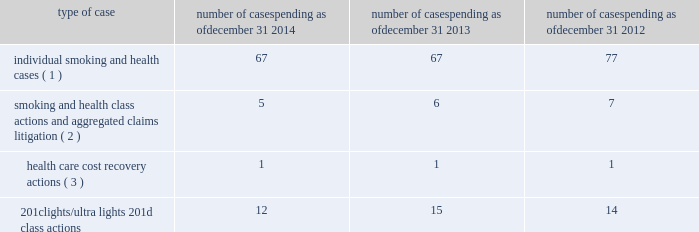Cases ; ( ii ) management is unable to estimate the possible loss or range of loss that could result from an unfavorable outcome in any of the pending tobacco-related cases ; and ( iii ) accordingly , management has not provided any amounts in the consolidated financial statements for unfavorable outcomes , if any .
Legal defense costs are expensed as incurred .
Altria group , inc .
And its subsidiaries have achieved substantial success in managing litigation .
Nevertheless , litigation is subject to uncertainty and significant challenges remain .
It is possible that the consolidated results of operations , cash flows or financial position of altria group , inc. , or one or more of its subsidiaries , could be materially affected in a particular fiscal quarter or fiscal year by an unfavorable outcome or settlement of certain pending litigation .
Altria group , inc .
And each of its subsidiaries named as a defendant believe , and each has been so advised by counsel handling the respective cases , that it has valid defenses to the litigation pending against it , as well as valid bases for appeal of adverse verdicts .
Each of the companies has defended , and will continue to defend , vigorously against litigation challenges .
However , altria group , inc .
And its subsidiaries may enter into settlement discussions in particular cases if they believe it is in the best interests of altria group , inc .
To do so .
Overview of altria group , inc .
And/or pm usa tobacco-related litigation types and number of cases : claims related to tobacco products generally fall within the following categories : ( i ) smoking and health cases alleging personal injury brought on behalf of individual plaintiffs ; ( ii ) smoking and health cases primarily alleging personal injury or seeking court- supervised programs for ongoing medical monitoring and purporting to be brought on behalf of a class of individual plaintiffs , including cases in which the aggregated claims of a number of individual plaintiffs are to be tried in a single proceeding ; ( iii ) health care cost recovery cases brought by governmental ( both domestic and foreign ) plaintiffs seeking reimbursement for health care expenditures allegedly caused by cigarette smoking and/or disgorgement of profits ; ( iv ) class action suits alleging that the uses of the terms 201clights 201d and 201cultra lights 201d constitute deceptive and unfair trade practices , common law or statutory fraud , unjust enrichment , breach of warranty or violations of the racketeer influenced and corrupt organizations act ( 201crico 201d ) ; and ( v ) other tobacco- related litigation described below .
Plaintiffs 2019 theories of recovery and the defenses raised in pending smoking and health , health care cost recovery and 201clights/ultra lights 201d cases are discussed below .
The table below lists the number of certain tobacco-related cases pending in the united states against pm usa and , in some instances , altria group , inc .
As of december 31 , 2014 , december 31 , 2013 and december 31 , 2012 .
Type of case number of cases pending as of december 31 , 2014 number of cases pending as of december 31 , 2013 number of cases pending as of december 31 , 2012 individual smoking and health cases ( 1 ) 67 67 77 smoking and health class actions and aggregated claims litigation ( 2 ) 5 6 7 health care cost recovery actions ( 3 ) 1 1 1 .
( 1 ) does not include 2558 cases brought by flight attendants seeking compensatory damages for personal injuries allegedly caused by exposure to environmental tobacco smoke ( 201cets 201d ) .
The flight attendants allege that they are members of an ets smoking and health class action in florida , which was settled in 1997 ( broin ) .
The terms of the court-approved settlement in that case allow class members to file individual lawsuits seeking compensatory damages , but prohibit them from seeking punitive damages .
Also , does not include individual smoking and health cases brought by or on behalf of plaintiffs in florida state and federal courts following the decertification of the engle case ( discussed below in smoking and health litigation - engle class action ) .
( 2 ) includes as one case the 600 civil actions ( of which 346 were actions against pm usa ) that were to be tried in a single proceeding in west virginia ( in re : tobacco litigation ) .
The west virginia supreme court of appeals has ruled that the united states constitution did not preclude a trial in two phases in this case .
Issues related to defendants 2019 conduct and whether punitive damages are permissible were tried in the first phase .
Trial in the first phase of this case began in april 2013 .
In may 2013 , the jury returned a verdict in favor of defendants on the claims for design defect , negligence , failure to warn , breach of warranty , and concealment and declined to find that the defendants 2019 conduct warranted punitive damages .
Plaintiffs prevailed on their claim that ventilated filter cigarettes should have included use instructions for the period 1964 - 1969 .
The second phase , if any , will consist of individual trials to determine liability and compensatory damages on that claim only .
In august 2013 , the trial court denied all post-trial motions .
The trial court entered final judgment in october 2013 and , in november 2013 , plaintiffs filed their notice of appeal to the west virginia supreme court of appeals .
On november 3 , 2014 , the west virginia supreme court of appeals affirmed the final judgment .
Plaintiffs filed a petition for rehearing with the west virginia supreme court of appeals , which the court denied on january 8 , 2015 .
( 3 ) see health care cost recovery litigation - federal government 2019s lawsuit below .
Altria group , inc .
And subsidiaries notes to consolidated financial statements _________________________ altria_mdc_2014form10k_nolinks_crops.pdf 68 2/25/15 5:56 pm .
What is the total tobacco-related cases pending in the united states as of december 31 , 2014? 
Computations: (((67 + 5) + 1) + 12)
Answer: 85.0. 